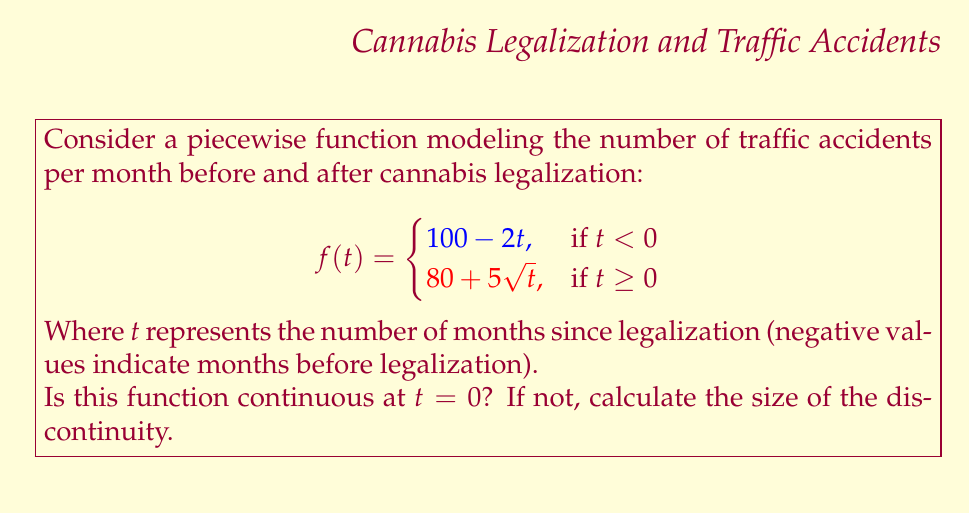Show me your answer to this math problem. To determine if the function is continuous at $t = 0$, we need to check three conditions:

1. $f(0)$ exists
2. $\lim_{t \to 0^-} f(t)$ exists
3. $\lim_{t \to 0^+} f(t)$ exists
4. All three values are equal

Let's evaluate each:

1. $f(0)$ exists:
   $f(0) = 80 + 5\sqrt{0} = 80$

2. $\lim_{t \to 0^-} f(t)$:
   $\lim_{t \to 0^-} (100 - 2t) = 100 - 2(0) = 100$

3. $\lim_{t \to 0^+} f(t)$:
   $\lim_{t \to 0^+} (80 + 5\sqrt{t}) = 80 + 5\sqrt{0} = 80$

We can see that $f(0) = \lim_{t \to 0^+} f(t) = 80$, but $\lim_{t \to 0^-} f(t) = 100$.

Since the left-hand limit doesn't equal the right-hand limit and the function value, the function is not continuous at $t = 0$.

To calculate the size of the discontinuity:

Size of discontinuity = $|\lim_{t \to 0^-} f(t) - \lim_{t \to 0^+} f(t)|$
                      = $|100 - 80|$
                      = $20$

This means there's a jump discontinuity of 20 traffic accidents per month at the point of legalization.
Answer: The function is not continuous at $t = 0$. The size of the discontinuity is 20. 